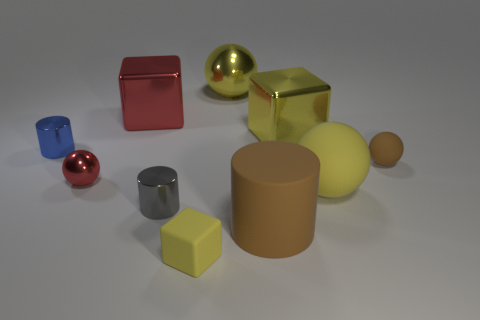There is a matte ball that is the same color as the big metal ball; what size is it? The matte ball sharing the same hue as the large metal sphere appears to be small in size, significantly smaller than its metallic counterpart. 